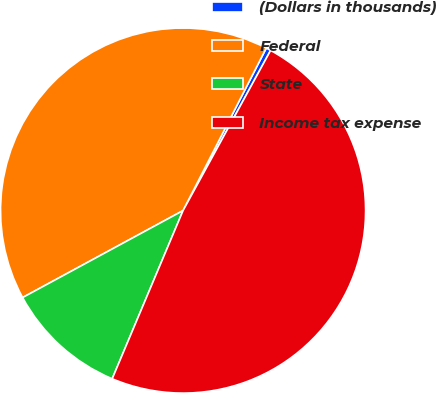Convert chart to OTSL. <chart><loc_0><loc_0><loc_500><loc_500><pie_chart><fcel>(Dollars in thousands)<fcel>Federal<fcel>State<fcel>Income tax expense<nl><fcel>0.43%<fcel>40.44%<fcel>10.75%<fcel>48.39%<nl></chart> 